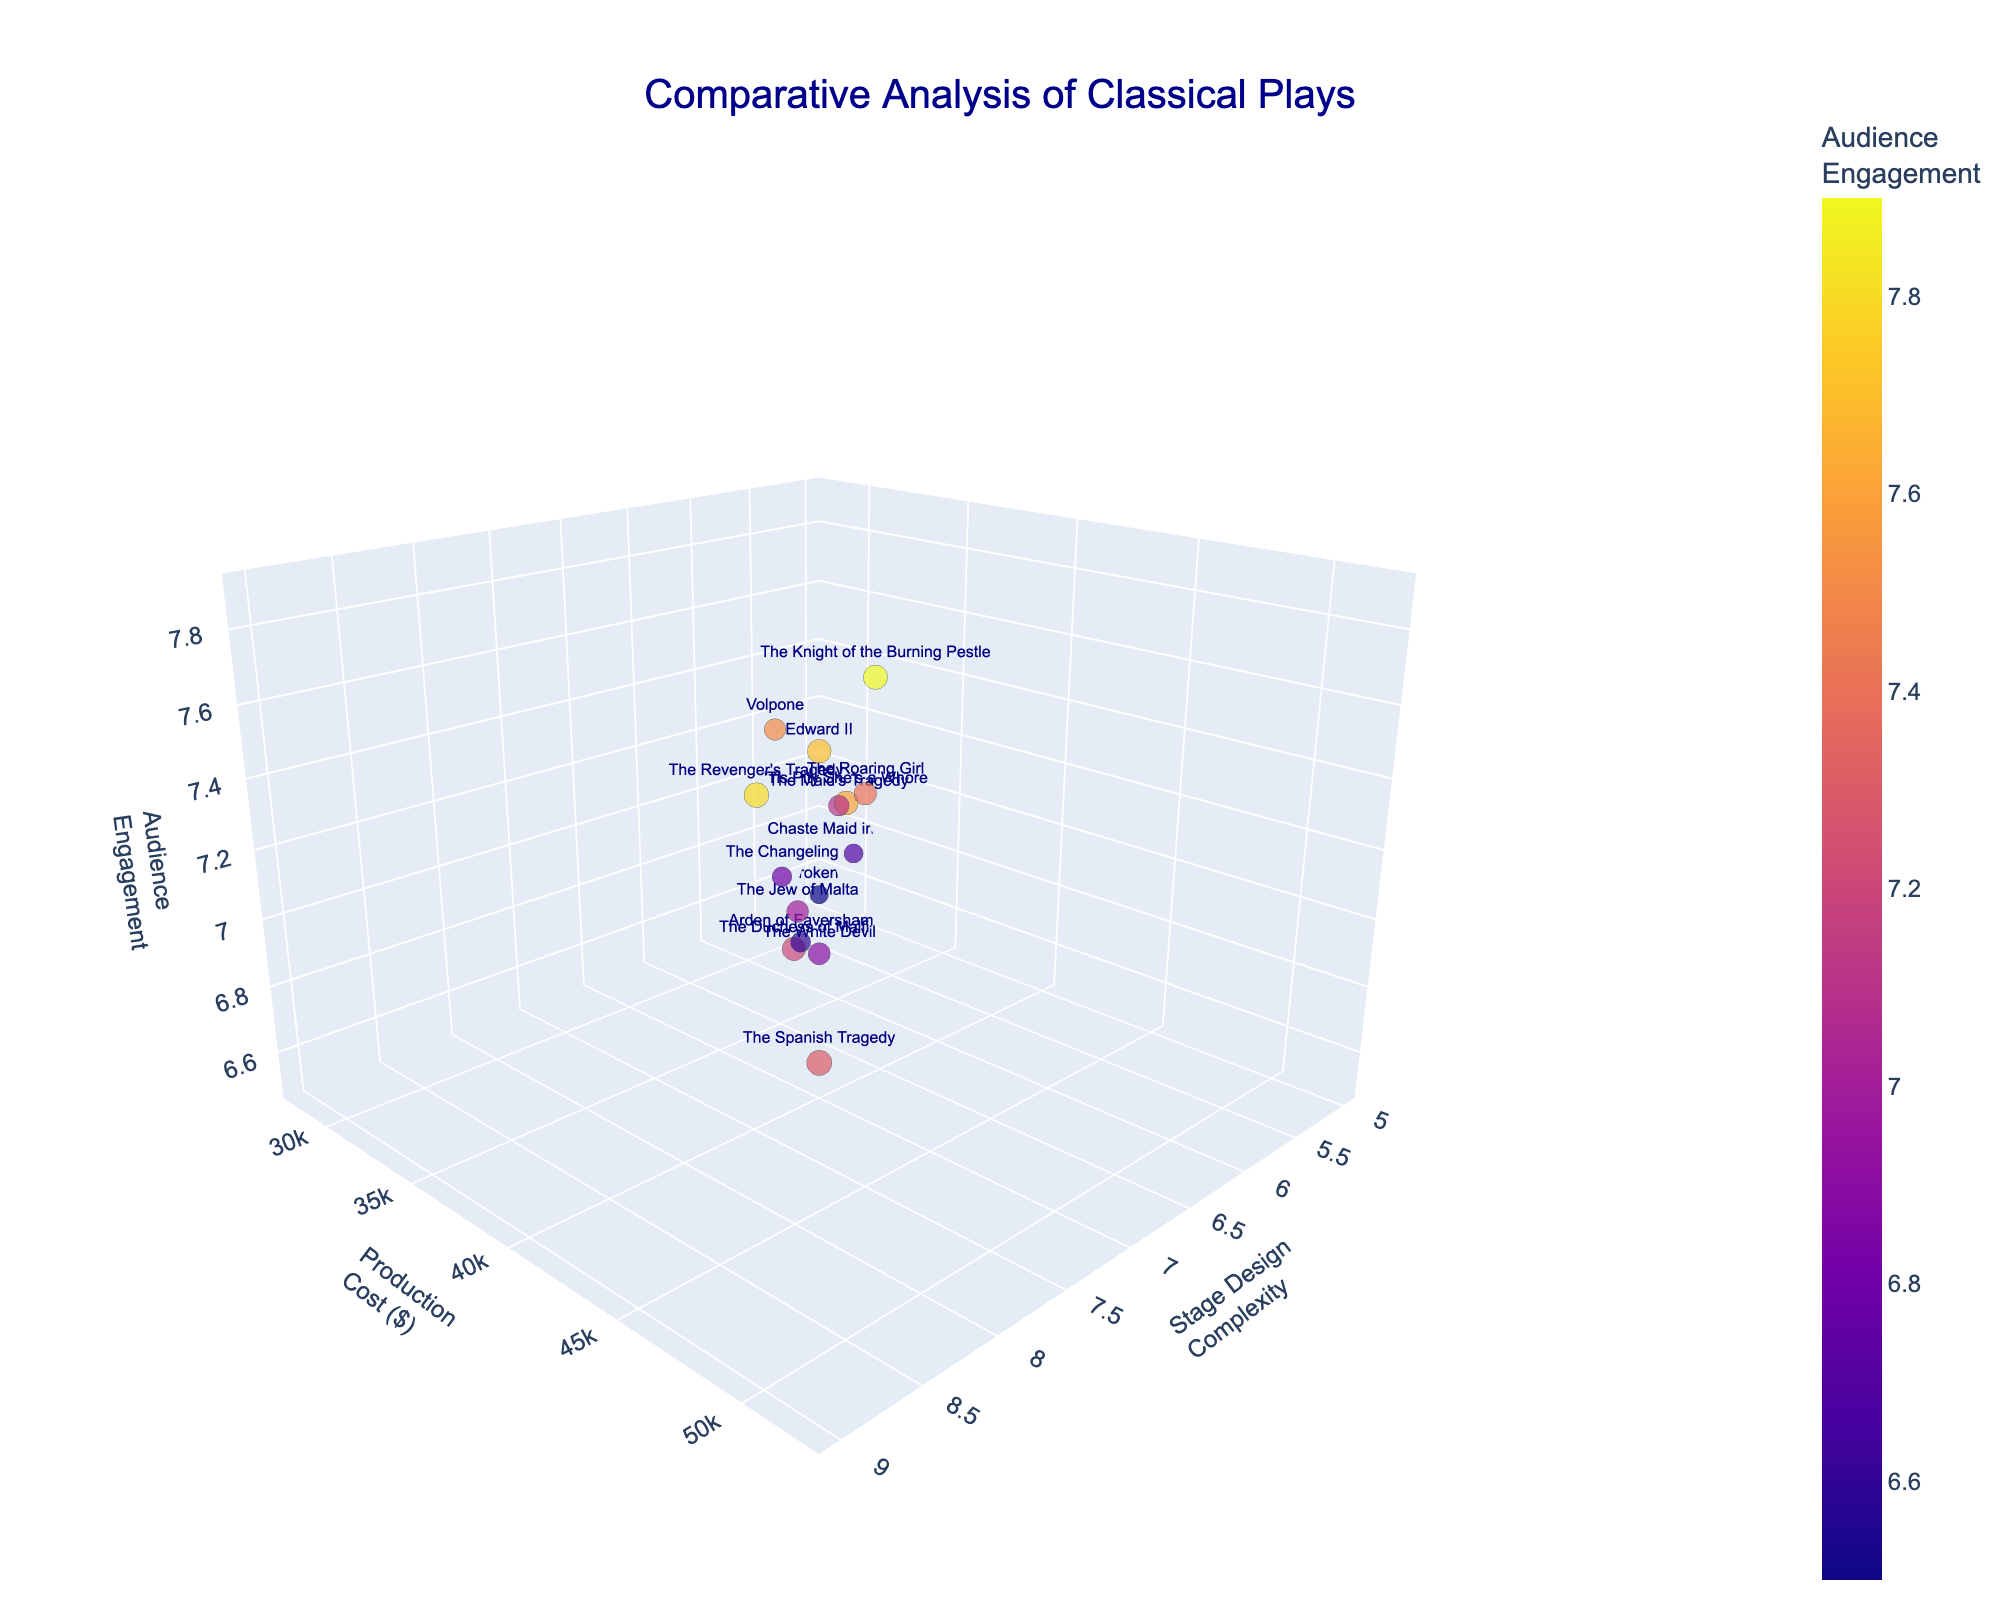What is the title of the figure? The title appears at the top of the figure in a larger font and distinct color (e.g., dark blue). From observing the title, it should read "Comparative Analysis of Classical Plays."
Answer: Comparative Analysis of Classical Plays Which play has the highest production cost? Look for the play with the highest value on the y-axis, labeled "Production Cost." The highest value on that axis should be $52,000, associated with "The Spanish Tragedy."
Answer: The Spanish Tragedy How many plays have a stage design complexity of 7? Count the data points sitting at Stage Design Complexity = 7 on the x-axis. The plays that match this are "Volpone," "The White Devil," "The Roaring Girl," and "The Jew of Malta."
Answer: Four plays Which play achieves the highest audience engagement? Look for the data point with the highest value on the z-axis, labeled "Audience Engagement." The highest value on this axis is 7.9, corresponding to "The Knight of the Burning Pestle."
Answer: The Knight of the Burning Pestle What is the combined production cost of plays with a stage design complexity of 5? Identify plays with Stage Design Complexity = 5, which are "The Broken Heart" and "A Chaste Maid in Cheapside." Add their production costs: $28,000 + $30,000 = $58,000.
Answer: $58,000 Which play has both the lowest stage design complexity and lowest audience engagement? Look for the least value on the x-axis (Stage Design Complexity), which is 5, and cross-check with the least value on the z-axis (Audience Engagement), which corresponds to "The Broken Heart" with 6.5 audience engagement.
Answer: The Broken Heart Which play has a higher production cost, "The Duchess of Malfi" or "'Tis Pity She's a Whore"? Compare the production costs of the two plays on the y-axis. “The Duchess of Malfi” has $45,000, whereas “'Tis Pity She's a Whore” has $47,000.
Answer: 'Tis Pity She's a Whore What's the average audience engagement of plays with a stage design complexity of 8? Identify plays with Stage Design Complexity = 8, which are "The Duchess of Malfi," "'Tis Pity She's a Whore," "The Knight of the Burning Pestle," and "Edward II." Their audience engagements are 7.2, 7.6, 7.9, and 7.7 respectively, average: (7.2 + 7.6 + 7.9 + 7.7) / 4 = 7.6.
Answer: 7.6 